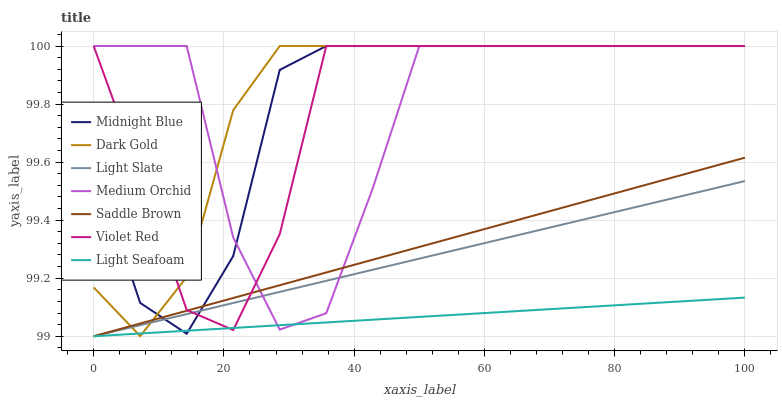Does Light Seafoam have the minimum area under the curve?
Answer yes or no. Yes. Does Dark Gold have the maximum area under the curve?
Answer yes or no. Yes. Does Midnight Blue have the minimum area under the curve?
Answer yes or no. No. Does Midnight Blue have the maximum area under the curve?
Answer yes or no. No. Is Light Slate the smoothest?
Answer yes or no. Yes. Is Medium Orchid the roughest?
Answer yes or no. Yes. Is Midnight Blue the smoothest?
Answer yes or no. No. Is Midnight Blue the roughest?
Answer yes or no. No. Does Midnight Blue have the lowest value?
Answer yes or no. No. Does Light Slate have the highest value?
Answer yes or no. No. 